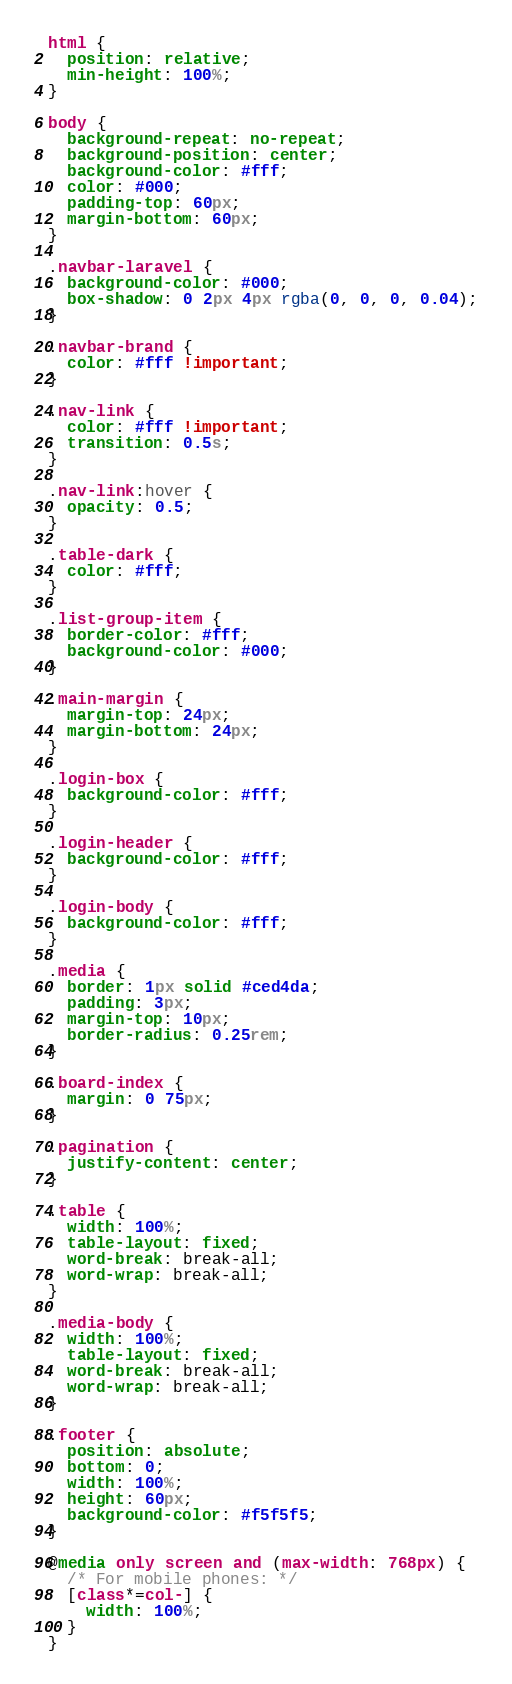<code> <loc_0><loc_0><loc_500><loc_500><_CSS_>html {
  position: relative;
  min-height: 100%;
}

body {
  background-repeat: no-repeat;
  background-position: center;
  background-color: #fff;
  color: #000;
  padding-top: 60px;
  margin-bottom: 60px;
}

.navbar-laravel {
  background-color: #000;
  box-shadow: 0 2px 4px rgba(0, 0, 0, 0.04);
}

.navbar-brand {
  color: #fff !important;
}

.nav-link {
  color: #fff !important;
  transition: 0.5s;
}

.nav-link:hover {
  opacity: 0.5;
}

.table-dark {
  color: #fff;
}

.list-group-item {
  border-color: #fff;
  background-color: #000;
}

.main-margin {
  margin-top: 24px;
  margin-bottom: 24px;
}

.login-box {
  background-color: #fff;
}

.login-header {
  background-color: #fff;
}

.login-body {
  background-color: #fff;
}

.media {
  border: 1px solid #ced4da;
  padding: 3px;
  margin-top: 10px;
  border-radius: 0.25rem;
}

.board-index {
  margin: 0 75px;
}

.pagination {
  justify-content: center;
}

.table {
  width: 100%;
  table-layout: fixed;
  word-break: break-all;
  word-wrap: break-all;
}

.media-body {
  width: 100%;
  table-layout: fixed;
  word-break: break-all;
  word-wrap: break-all;
}

.footer {
  position: absolute;
  bottom: 0;
  width: 100%;
  height: 60px;
  background-color: #f5f5f5;
}

@media only screen and (max-width: 768px) {
  /* For mobile phones: */
  [class*=col-] {
    width: 100%;
  }
}</code> 